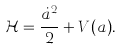<formula> <loc_0><loc_0><loc_500><loc_500>\mathcal { H } = \frac { \dot { a } ^ { 2 } } { 2 } + V ( a ) .</formula> 